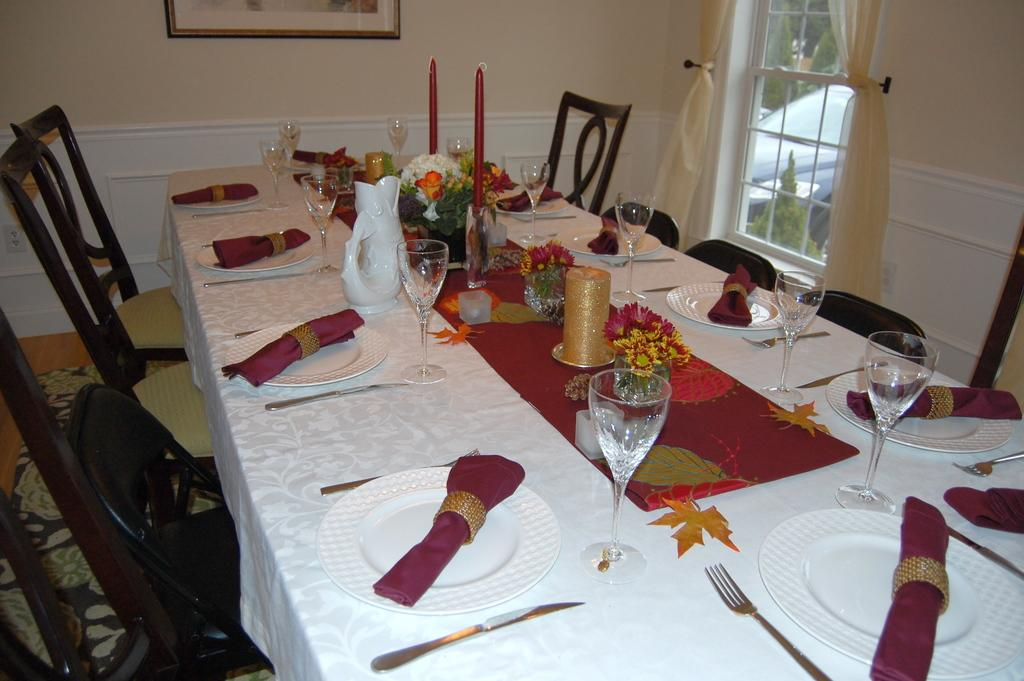What type of furniture is in the image? There is a dining table in the image. What is on the dining table? The dining table has white plates on it. What color clothes can be seen in the image? There are red clothes in the image. What is visible in the background of the image? There is a glass window and a wall visible in the background. What type of weather can be seen in the cemetery in the image? There is no cemetery present in the image, and therefore no weather can be observed in relation to it. 